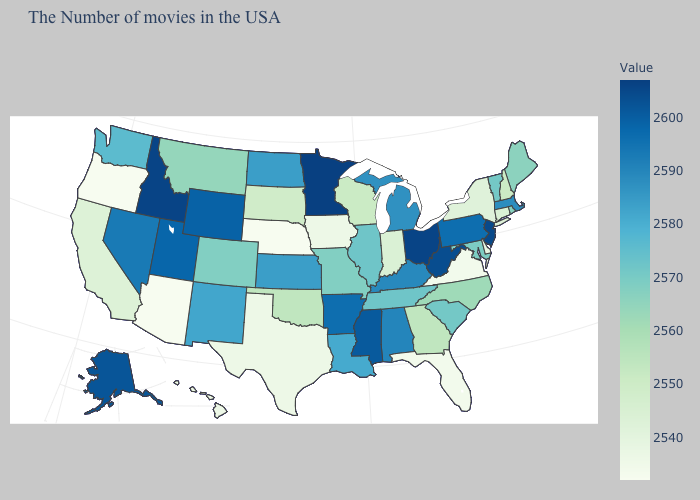Does Nebraska have the lowest value in the MidWest?
Short answer required. Yes. Does Vermont have the lowest value in the USA?
Short answer required. No. Does Utah have a lower value than Idaho?
Keep it brief. Yes. 